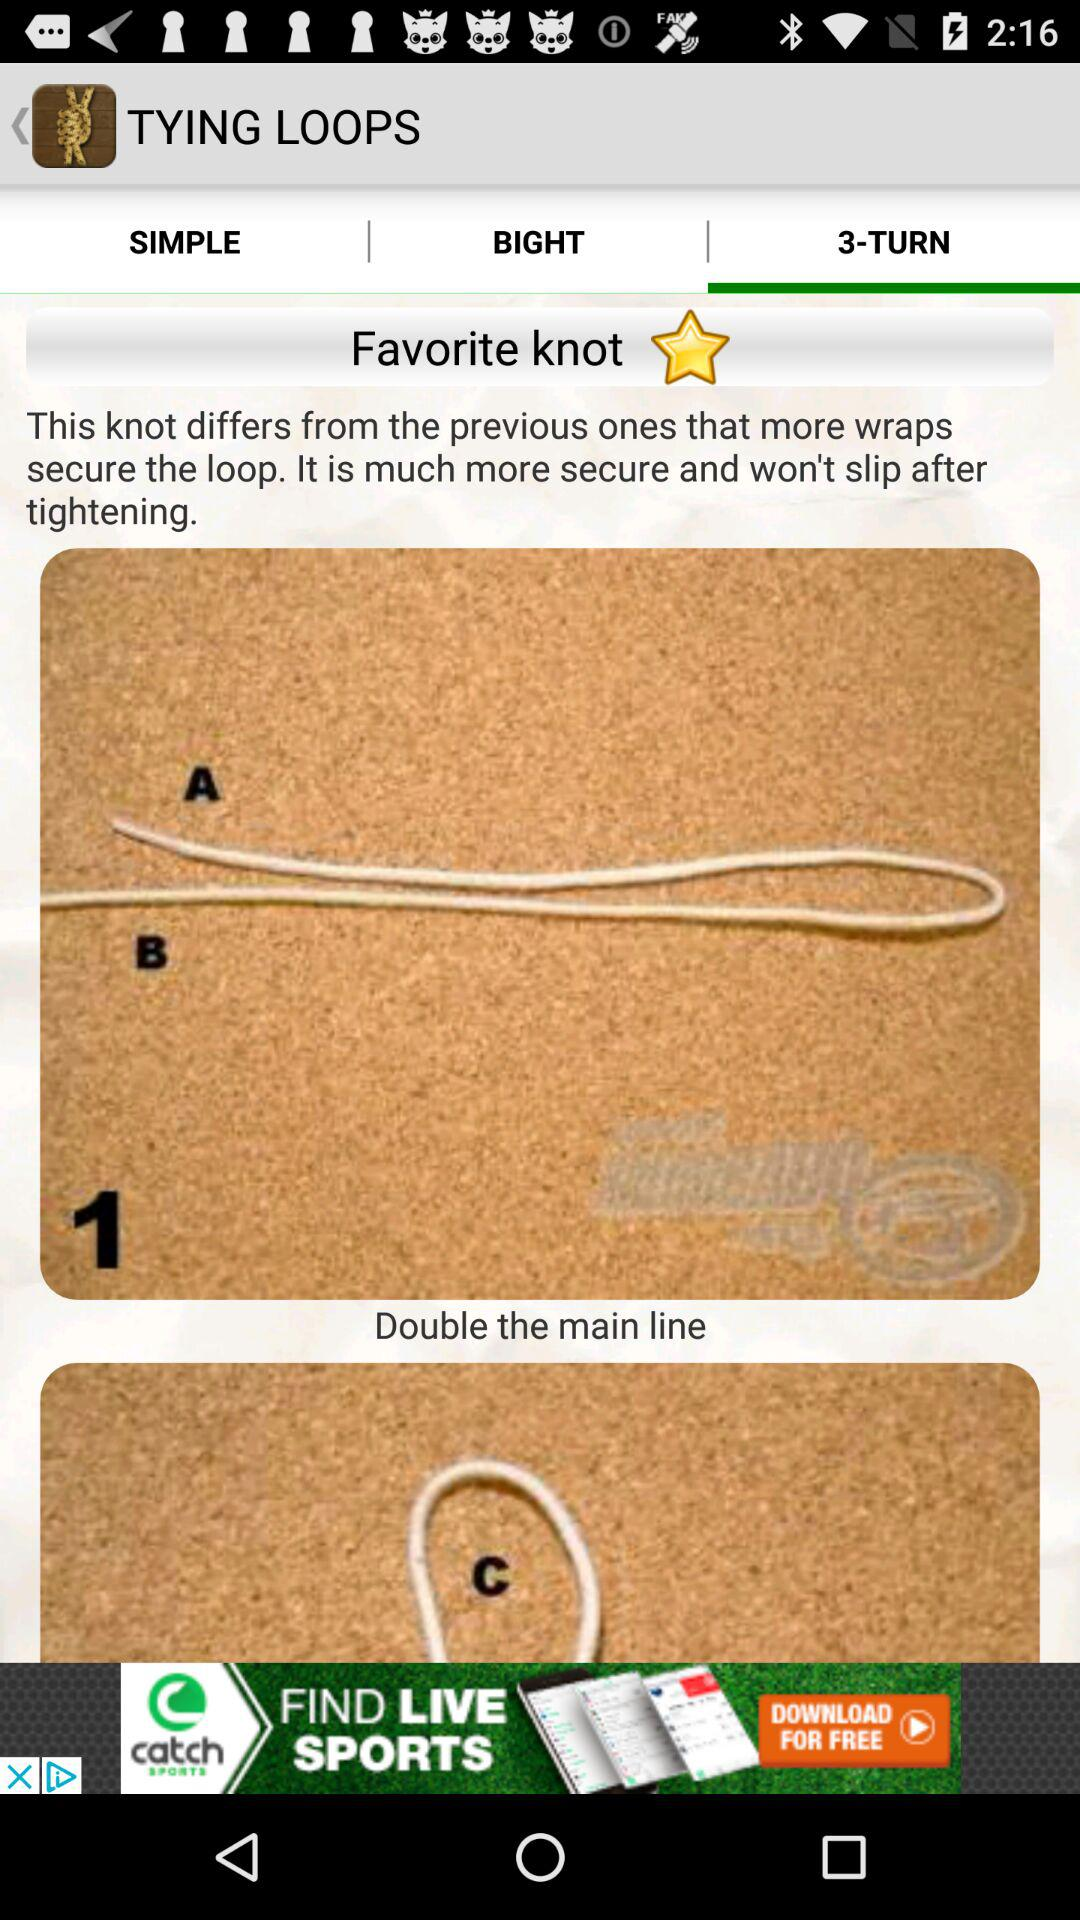How many more steps are there in the 3-turn knot than in the simple knot?
Answer the question using a single word or phrase. 2 